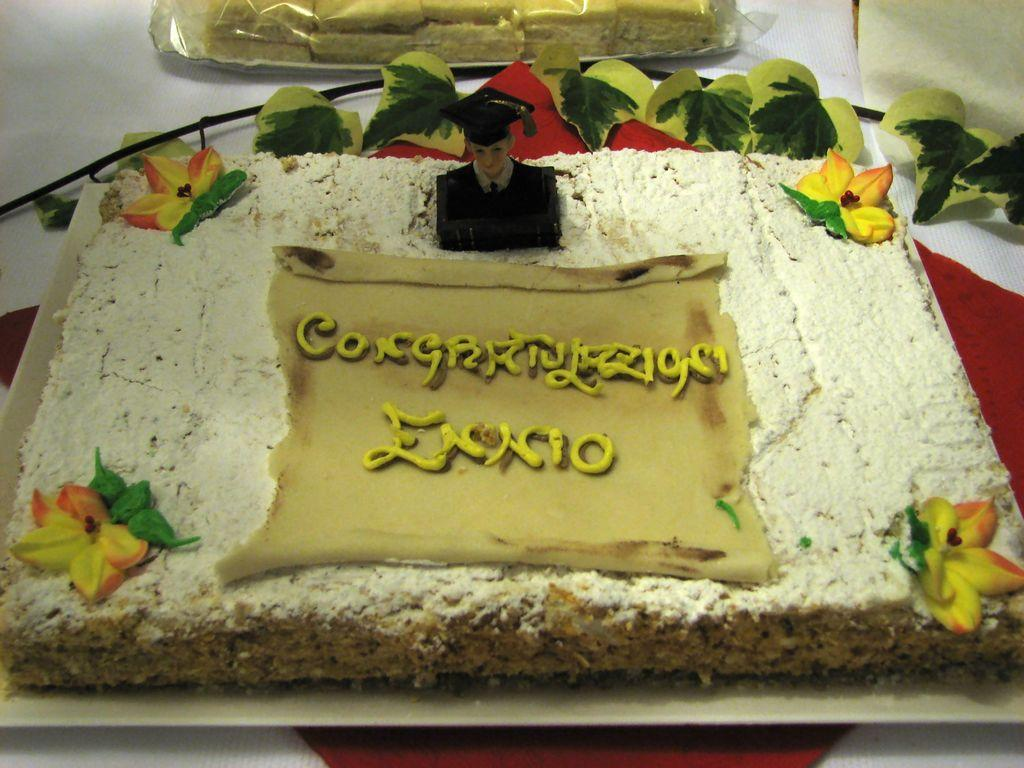What is the main food item visible in the image? There is a cake on a plate in the image. What type of vegetation can be seen in the image? Leaves are present in the image. What is the surface on which the food items are placed? There are food items on a cloth in the image. What type of drug is visible on the cake in the image? There is no drug present on the cake or in the image. Can you describe the boot that is placed next to the cake? There is no boot present in the image; it only features a cake, leaves, and food items on a cloth. 